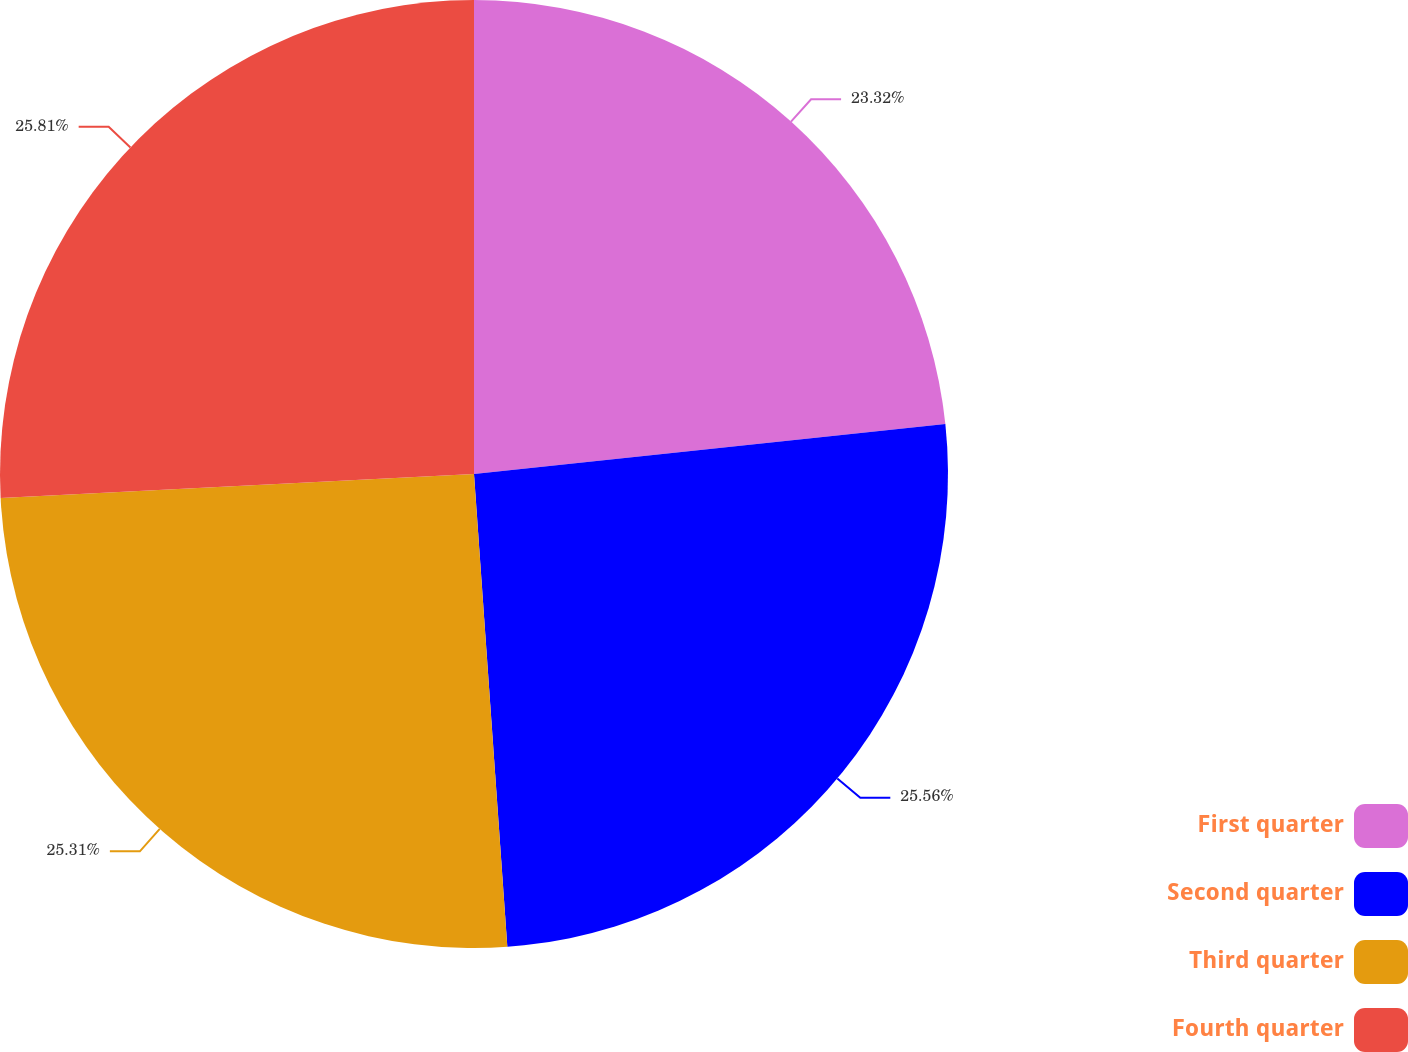<chart> <loc_0><loc_0><loc_500><loc_500><pie_chart><fcel>First quarter<fcel>Second quarter<fcel>Third quarter<fcel>Fourth quarter<nl><fcel>23.32%<fcel>25.56%<fcel>25.31%<fcel>25.81%<nl></chart> 